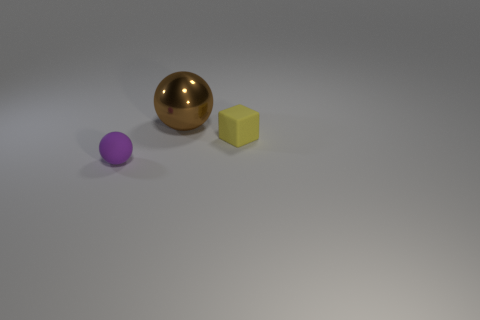What number of tiny things are both behind the small purple rubber ball and to the left of the tiny yellow thing?
Make the answer very short. 0. Do the object left of the brown metal sphere and the rubber thing on the right side of the tiny matte ball have the same size?
Ensure brevity in your answer.  Yes. There is a purple rubber thing; are there any large brown metallic objects right of it?
Your answer should be very brief. Yes. There is a tiny object to the left of the tiny thing that is to the right of the metal ball; what is its color?
Your answer should be compact. Purple. Are there fewer tiny rubber blocks than tiny objects?
Your answer should be very brief. Yes. What number of other large shiny things have the same shape as the big brown metal thing?
Your response must be concise. 0. There is a ball that is the same size as the yellow object; what color is it?
Ensure brevity in your answer.  Purple. Are there the same number of yellow things right of the brown object and big brown spheres behind the purple matte thing?
Ensure brevity in your answer.  Yes. Are there any other gray matte spheres of the same size as the matte sphere?
Ensure brevity in your answer.  No. How big is the brown ball?
Your response must be concise. Large. 